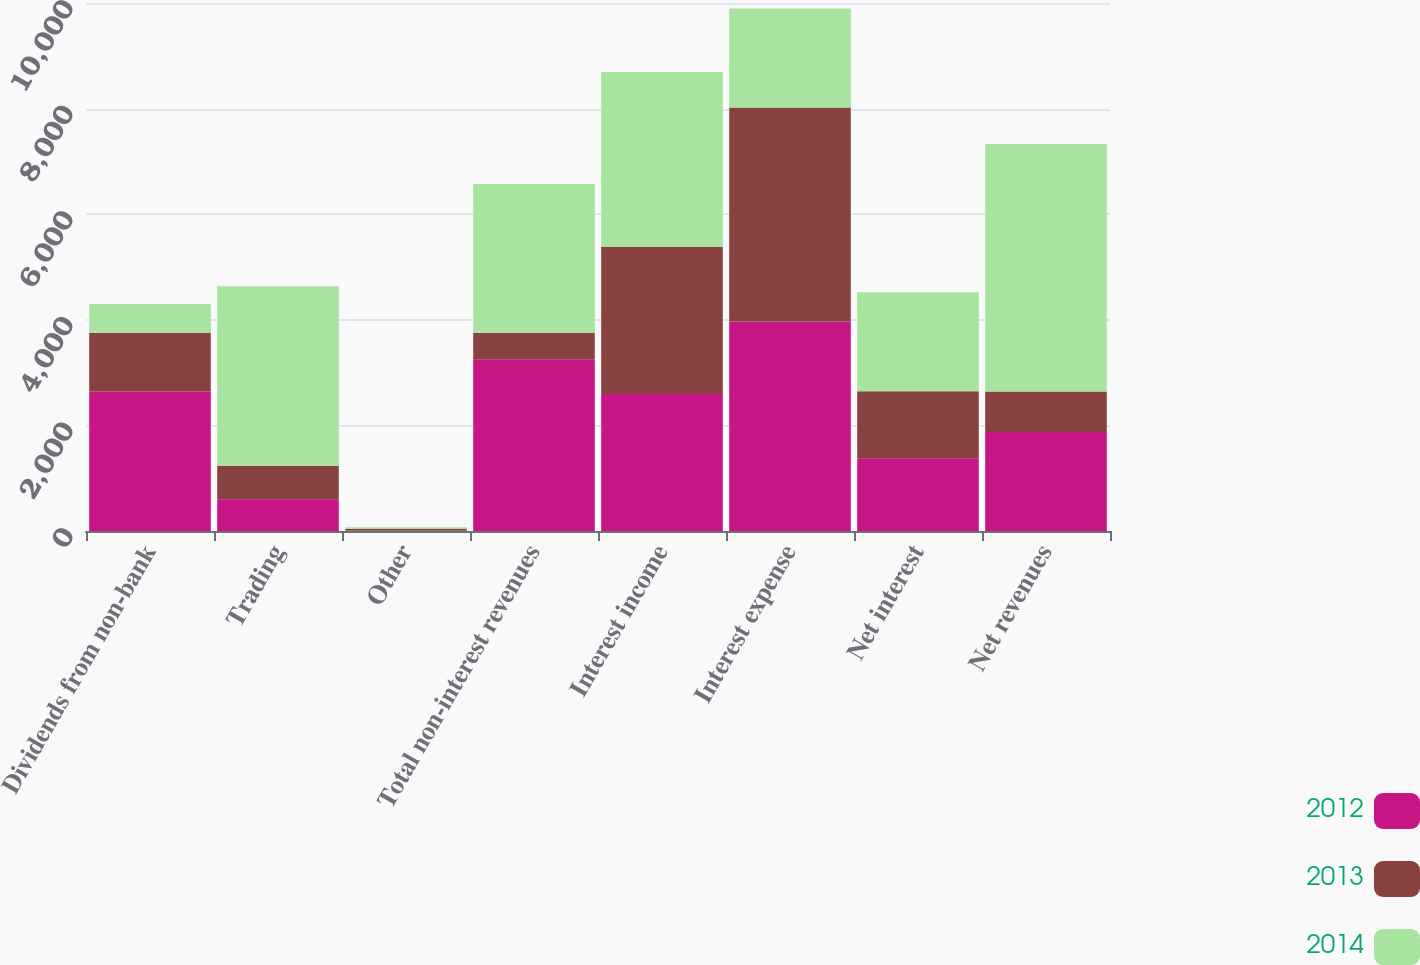Convert chart to OTSL. <chart><loc_0><loc_0><loc_500><loc_500><stacked_bar_chart><ecel><fcel>Dividends from non-bank<fcel>Trading<fcel>Other<fcel>Total non-interest revenues<fcel>Interest income<fcel>Interest expense<fcel>Net interest<fcel>Net revenues<nl><fcel>2012<fcel>2641<fcel>601<fcel>10<fcel>3251<fcel>2594<fcel>3970<fcel>1376<fcel>1875<nl><fcel>2013<fcel>1113<fcel>635<fcel>27<fcel>505<fcel>2783<fcel>4053<fcel>1270<fcel>765<nl><fcel>2014<fcel>545<fcel>3400<fcel>36<fcel>2817<fcel>3316<fcel>1874<fcel>1874<fcel>4691<nl></chart> 